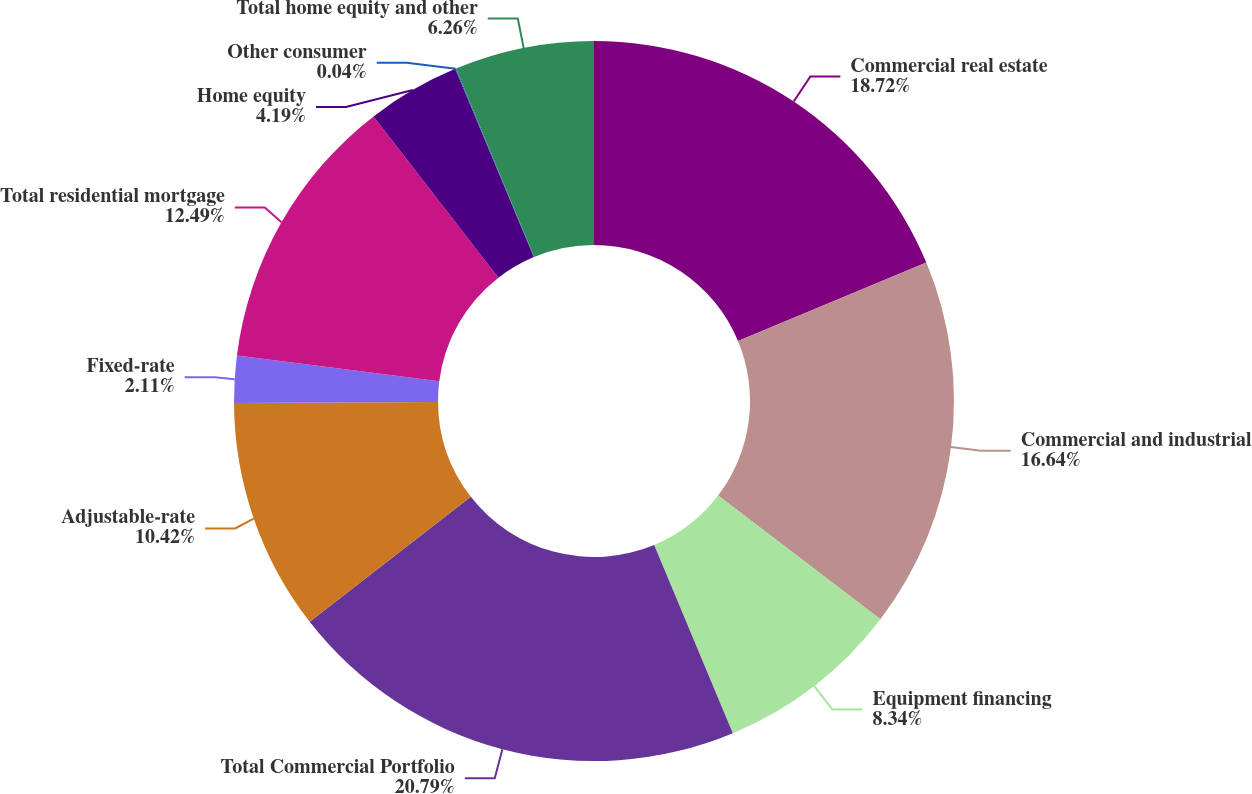Convert chart to OTSL. <chart><loc_0><loc_0><loc_500><loc_500><pie_chart><fcel>Commercial real estate<fcel>Commercial and industrial<fcel>Equipment financing<fcel>Total Commercial Portfolio<fcel>Adjustable-rate<fcel>Fixed-rate<fcel>Total residential mortgage<fcel>Home equity<fcel>Other consumer<fcel>Total home equity and other<nl><fcel>18.72%<fcel>16.64%<fcel>8.34%<fcel>20.79%<fcel>10.42%<fcel>2.11%<fcel>12.49%<fcel>4.19%<fcel>0.04%<fcel>6.26%<nl></chart> 